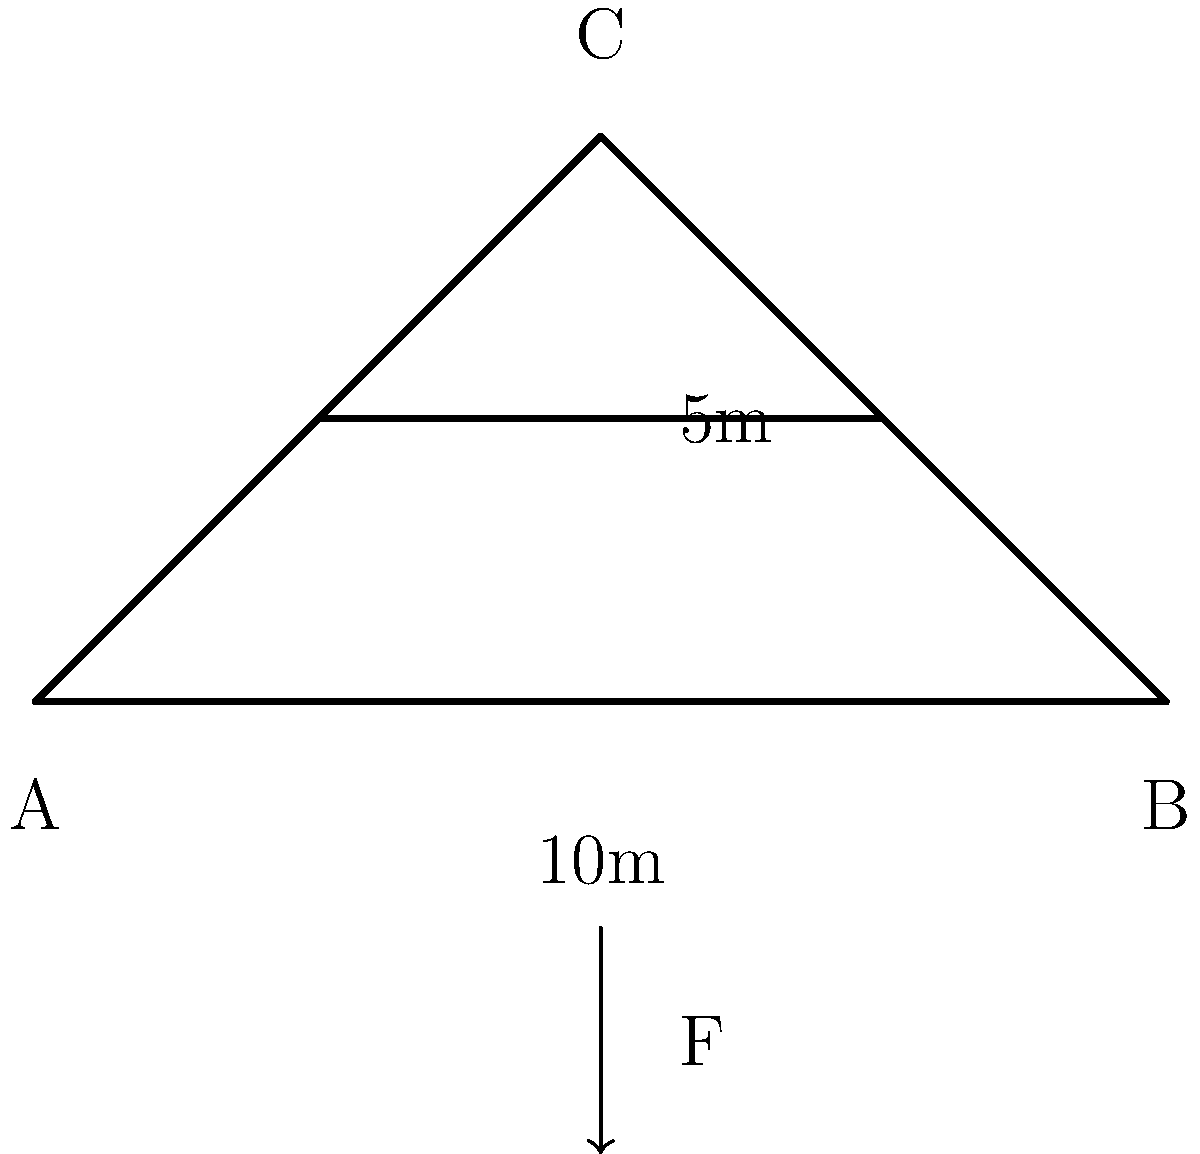A simple truss bridge is designed as shown in the figure above. The bridge span is 10 meters, and the height at the center is 5 meters. Assuming all members are made of steel with a yield strength of 250 MPa and a cross-sectional area of 0.002 m², calculate the maximum load (F) that can be applied at the center of the bridge before any member yields. Neglect the weight of the bridge itself. To solve this problem, we'll follow these steps:

1. Identify the critical member:
   The most stressed member will be either AC or BC due to the central load.

2. Calculate the angle θ between the diagonal member and the horizontal:
   $\tan \theta = \frac{5}{5} = 1$, so $\theta = 45°$

3. Calculate the force in the diagonal member (AC or BC):
   Using the method of joints at point C:
   $F_{\text{diagonal}} \cdot \cos 45° = F/2$
   $F_{\text{diagonal}} = \frac{F}{2 \cos 45°} = \frac{F}{2 \cdot 0.707} = 0.707F$

4. Set up the yield condition:
   Stress in the diagonal member = Force / Area ≤ Yield strength
   $\frac{0.707F}{0.002} \leq 250 \times 10^6$

5. Solve for F:
   $0.707F \leq 250 \times 10^6 \times 0.002$
   $F \leq \frac{250 \times 10^6 \times 0.002}{0.707} = 707,214 N$

Therefore, the maximum load that can be applied at the center of the bridge before any member yields is approximately 707 kN.
Answer: 707 kN 